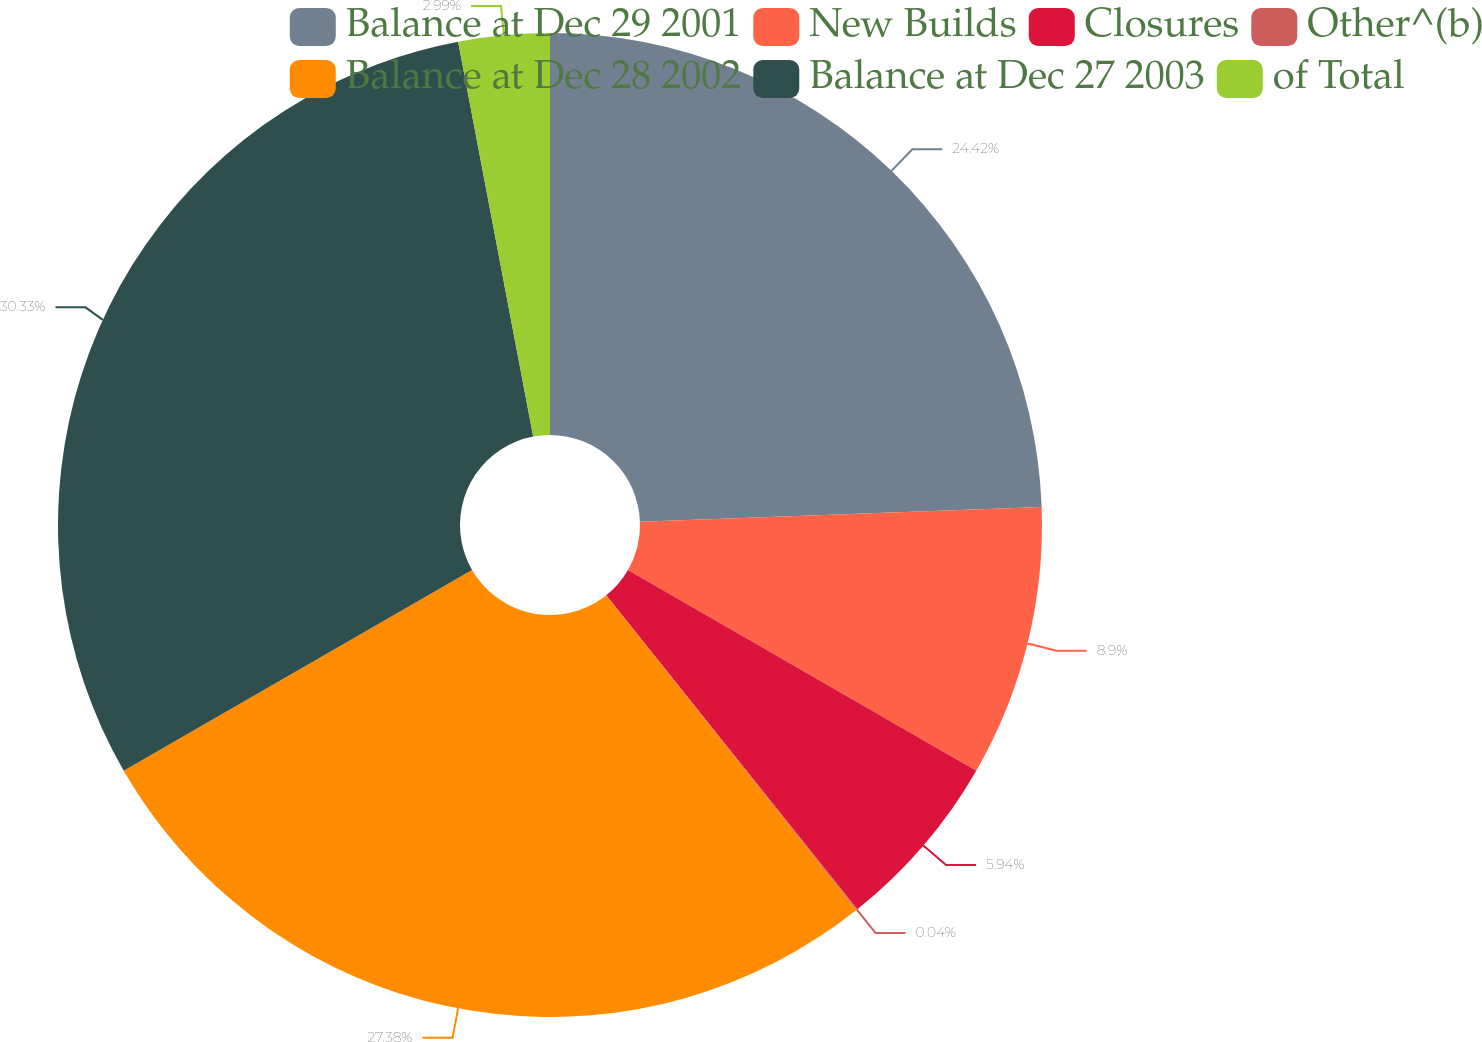<chart> <loc_0><loc_0><loc_500><loc_500><pie_chart><fcel>Balance at Dec 29 2001<fcel>New Builds<fcel>Closures<fcel>Other^(b)<fcel>Balance at Dec 28 2002<fcel>Balance at Dec 27 2003<fcel>of Total<nl><fcel>24.42%<fcel>8.9%<fcel>5.94%<fcel>0.04%<fcel>27.38%<fcel>30.33%<fcel>2.99%<nl></chart> 